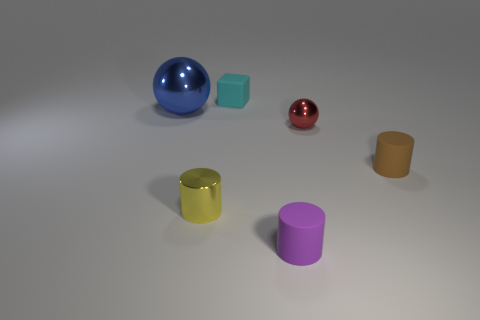Add 1 small rubber blocks. How many objects exist? 7 Subtract all cubes. How many objects are left? 5 Add 2 tiny brown cylinders. How many tiny brown cylinders are left? 3 Add 6 red spheres. How many red spheres exist? 7 Subtract 0 gray cylinders. How many objects are left? 6 Subtract all blue balls. Subtract all large balls. How many objects are left? 4 